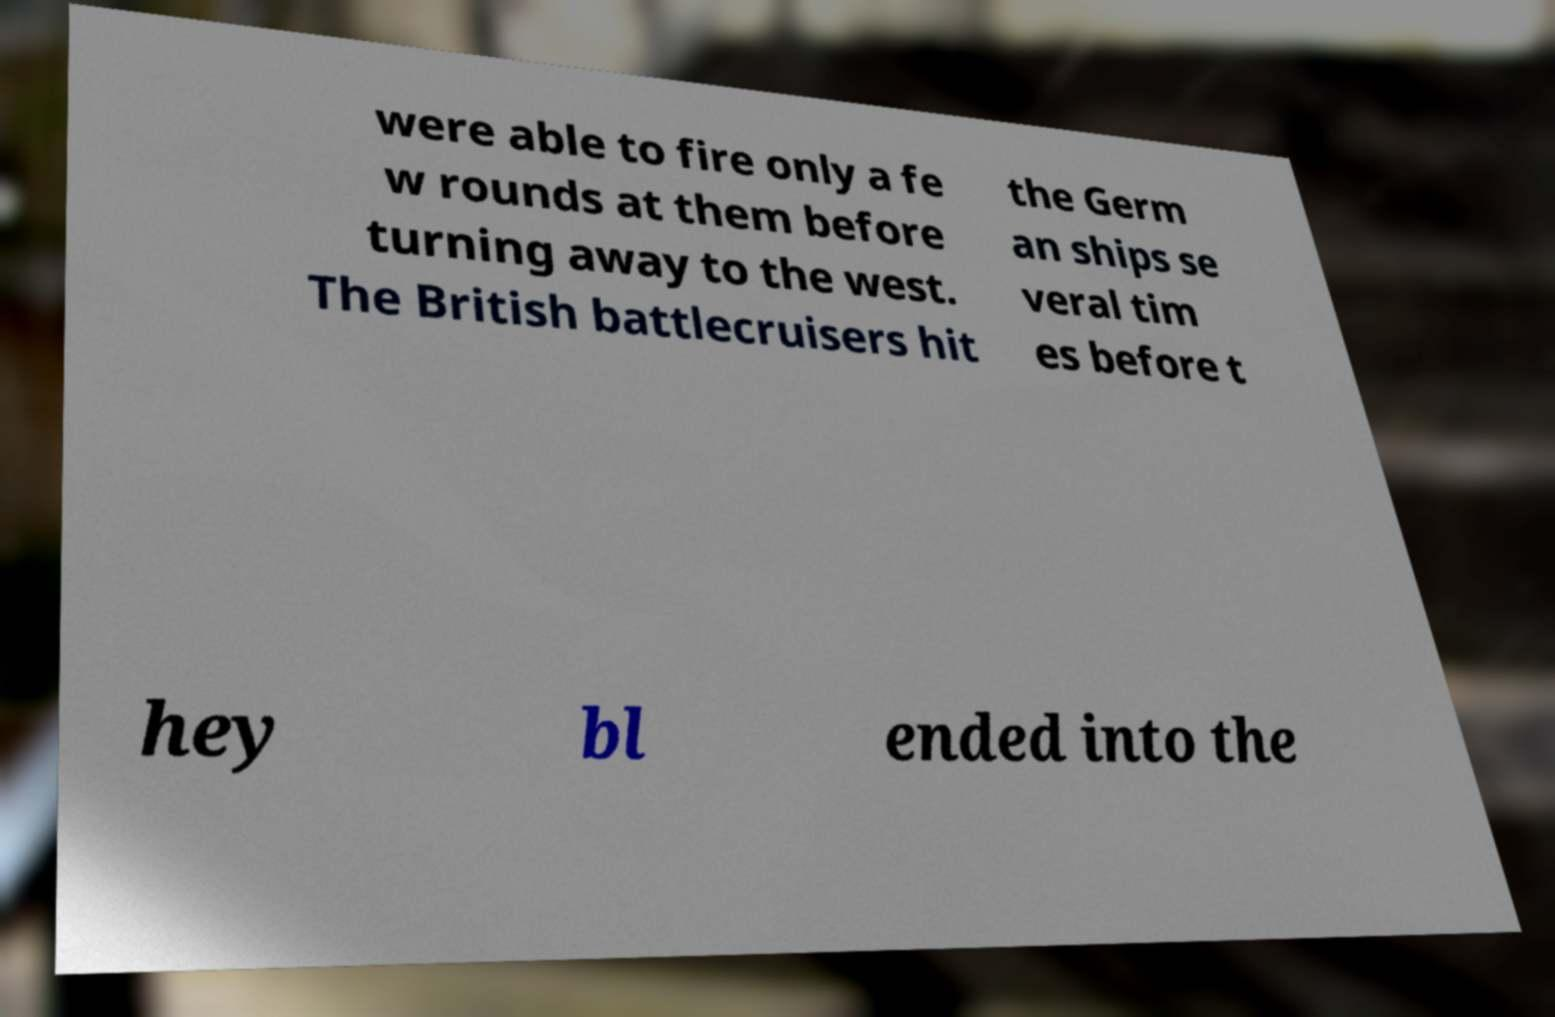Please identify and transcribe the text found in this image. were able to fire only a fe w rounds at them before turning away to the west. The British battlecruisers hit the Germ an ships se veral tim es before t hey bl ended into the 